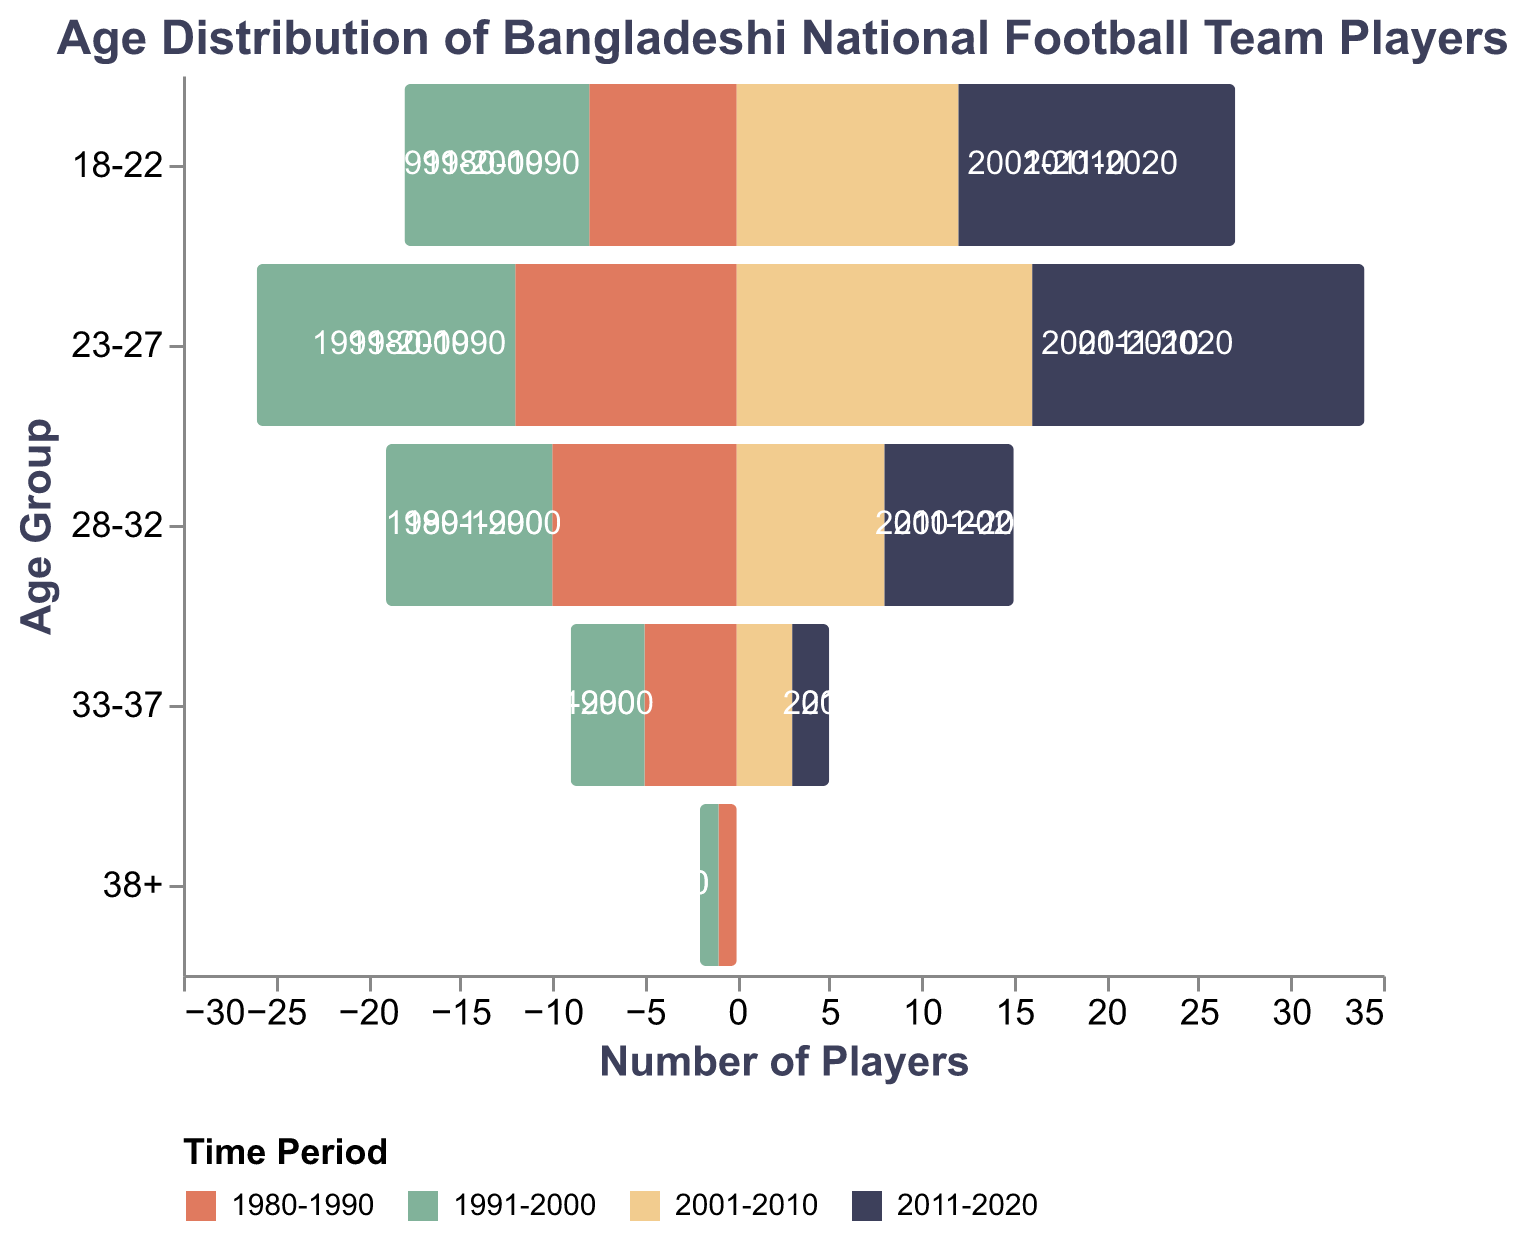What is the title of the figure? The title is located at the top of the figure and is usually a short text summarizing what the graph is about.
Answer: Age Distribution of Bangladeshi National Football Team Players Which age group had the highest number of players in 2011-2020? By looking at the bars in the population pyramid for the 2011-2020 period, we can see which age group has the longest bar.
Answer: 18-22 How did the number of players aged 33-37 change from 1980-1990 to 2011-2020? Compare the lengths of the bars for the age group 33-37 between 1980-1990 and 2011-2020.
Answer: It decreased from 5 to 2 What was the total number of players aged 18-22 and 23-27 in 2001-2010? Add the numbers of players in the 18-22 and 23-27 age groups for the 2001-2010 period (12 + 16).
Answer: 28 Which time period had the least number of players aged 28-32? Find the smallest value from the bars representing the 28-32 age group across all time periods.
Answer: 2011-2020 How many more players were there in the age group 18-22 in 2011-2020 compared to 1980-1990? Subtract the number of players in the 18-22 age group in 1980-1990 from the number in 2011-2020 (15 - 8).
Answer: 7 Did any age group disappear entirely by the 2000s? Check the number of players across all age groups and see if any age group had zero players by the 2000s (2001-2010 and 2011-2020 periods).
Answer: Yes, the age group 38+ Between the periods 1980-1990 and 1991-2000, was there an increase or decrease in the number of players aged 23-27? Compare the lengths of the bars for 23-27 between these two periods.
Answer: Increase What trend can be observed about the number of players in the age group 18-22 over the decades? Look at the bars for the age group 18-22 and describe the trend in their length over the four time periods.
Answer: Increasing Which color represents the 2001-2010 period? The legend in the figure assigns specific colors to each time period; find the color associated with 2001-2010.
Answer: Yellow 